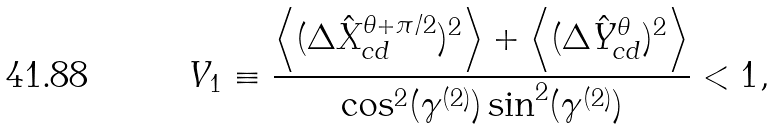<formula> <loc_0><loc_0><loc_500><loc_500>V _ { 1 } \equiv \frac { \left \langle ( \Delta \hat { X } _ { c d } ^ { \theta + \pi / 2 } ) ^ { 2 } \right \rangle + \left \langle ( \Delta \hat { Y } _ { c d } ^ { \theta } ) ^ { 2 } \right \rangle } { \cos ^ { 2 } ( \gamma ^ { ( 2 ) } ) \sin ^ { 2 } ( \gamma ^ { ( 2 ) } ) } < 1 ,</formula> 